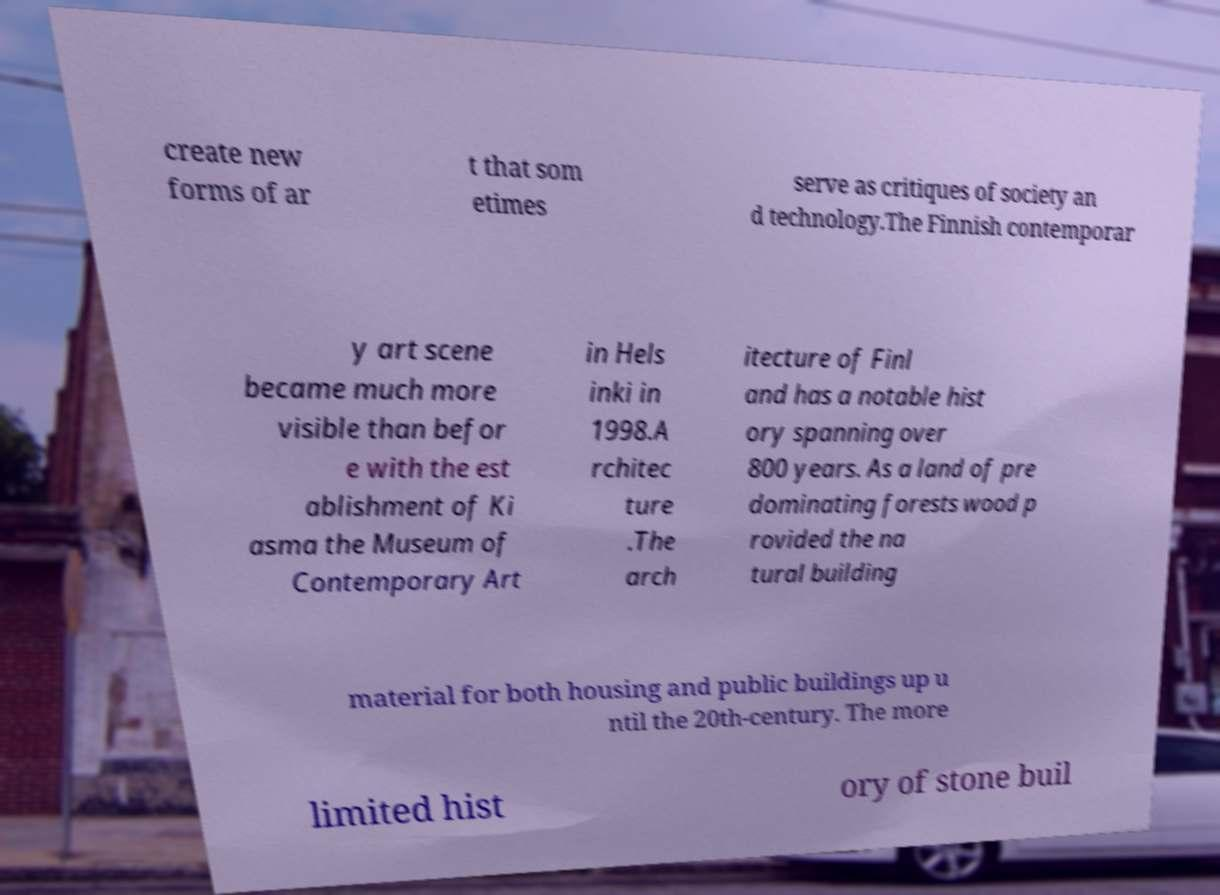For documentation purposes, I need the text within this image transcribed. Could you provide that? create new forms of ar t that som etimes serve as critiques of society an d technology.The Finnish contemporar y art scene became much more visible than befor e with the est ablishment of Ki asma the Museum of Contemporary Art in Hels inki in 1998.A rchitec ture .The arch itecture of Finl and has a notable hist ory spanning over 800 years. As a land of pre dominating forests wood p rovided the na tural building material for both housing and public buildings up u ntil the 20th-century. The more limited hist ory of stone buil 